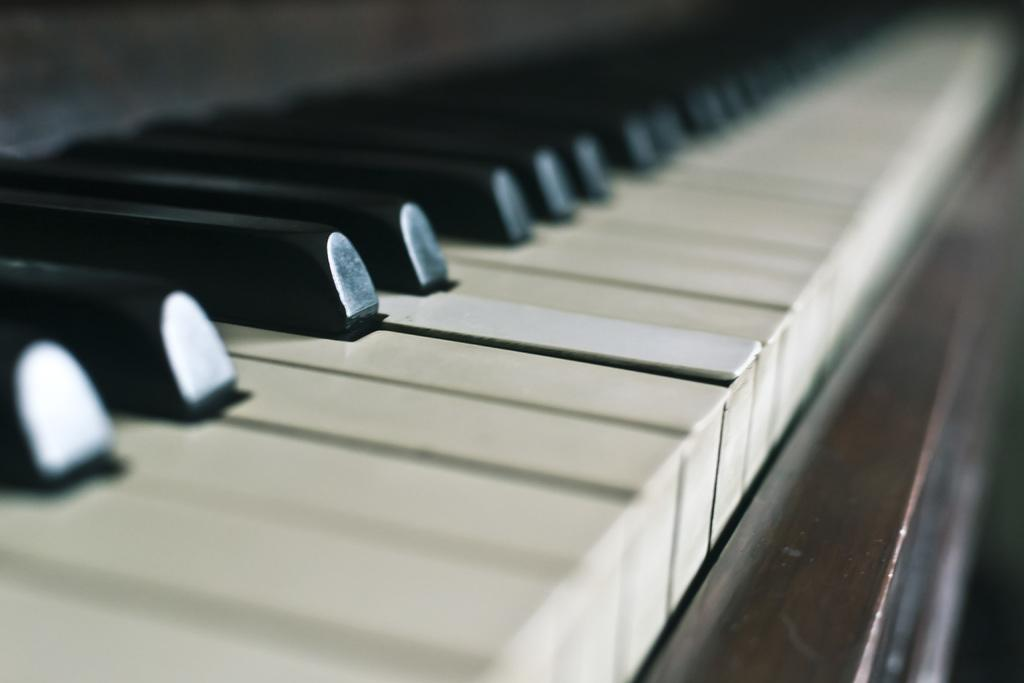What musical instrument is present in the image? There is a piano in the image. What type of sound does the piano produce? The piano produces a variety of musical notes and tones when its keys are pressed. Can you describe the appearance of the piano in the image? The piano appears to be a traditional, upright piano with a wooden finish. What type of fruit is being used as a decoration on the piano in the image? There is no fruit present on the piano in the image; it is a piano without any additional decorations. 